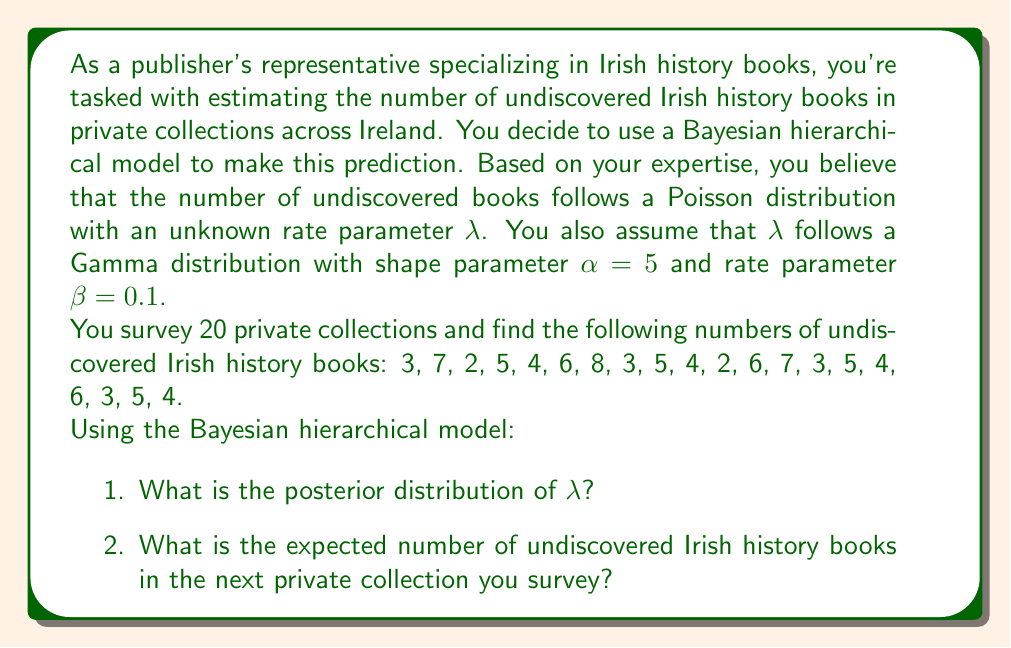Could you help me with this problem? Let's approach this problem step by step using the Bayesian hierarchical model:

1. Prior distribution:
   We're given that $\lambda \sim \text{Gamma}(\alpha, \beta)$ with $\alpha = 5$ and $\beta = 0.1$.

2. Likelihood:
   The number of books in each collection follows a Poisson distribution with rate $\lambda$.

3. Data:
   We have observations from 20 collections. Let's calculate the sum and count:
   
   Sum of observations: $\sum_{i=1}^{20} x_i = 92$
   Number of observations: $n = 20$

4. Posterior distribution:
   In a Poisson-Gamma model, the posterior distribution of $\lambda$ is also a Gamma distribution:

   $\lambda | x \sim \text{Gamma}(\alpha + \sum_{i=1}^{n} x_i, \beta + n)$

   Substituting our values:
   $\lambda | x \sim \text{Gamma}(5 + 92, 0.1 + 20) = \text{Gamma}(97, 20.1)$

5. Expected value of the posterior distribution:
   For a Gamma distribution, the expected value is $\frac{\text{shape}}{\text{rate}}$:

   $E[\lambda | x] = \frac{97}{20.1} \approx 4.826$

6. Predicted number of books in the next collection:
   This follows a Poisson distribution with rate equal to the expected value of $\lambda$:

   $E[X_{new} | x] = E[\lambda | x] \approx 4.826$

Therefore, the posterior distribution of $\lambda$ is Gamma(97, 20.1), and the expected number of undiscovered Irish history books in the next private collection is approximately 4.826.
Answer: 1. The posterior distribution of $\lambda$ is $\text{Gamma}(97, 20.1)$.
2. The expected number of undiscovered Irish history books in the next private collection is approximately 4.826. 